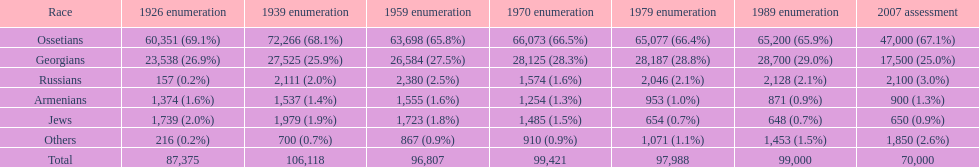How many ethnicity is there? 6. 